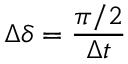<formula> <loc_0><loc_0><loc_500><loc_500>\Delta \delta = \frac { \pi / 2 } { \Delta t }</formula> 